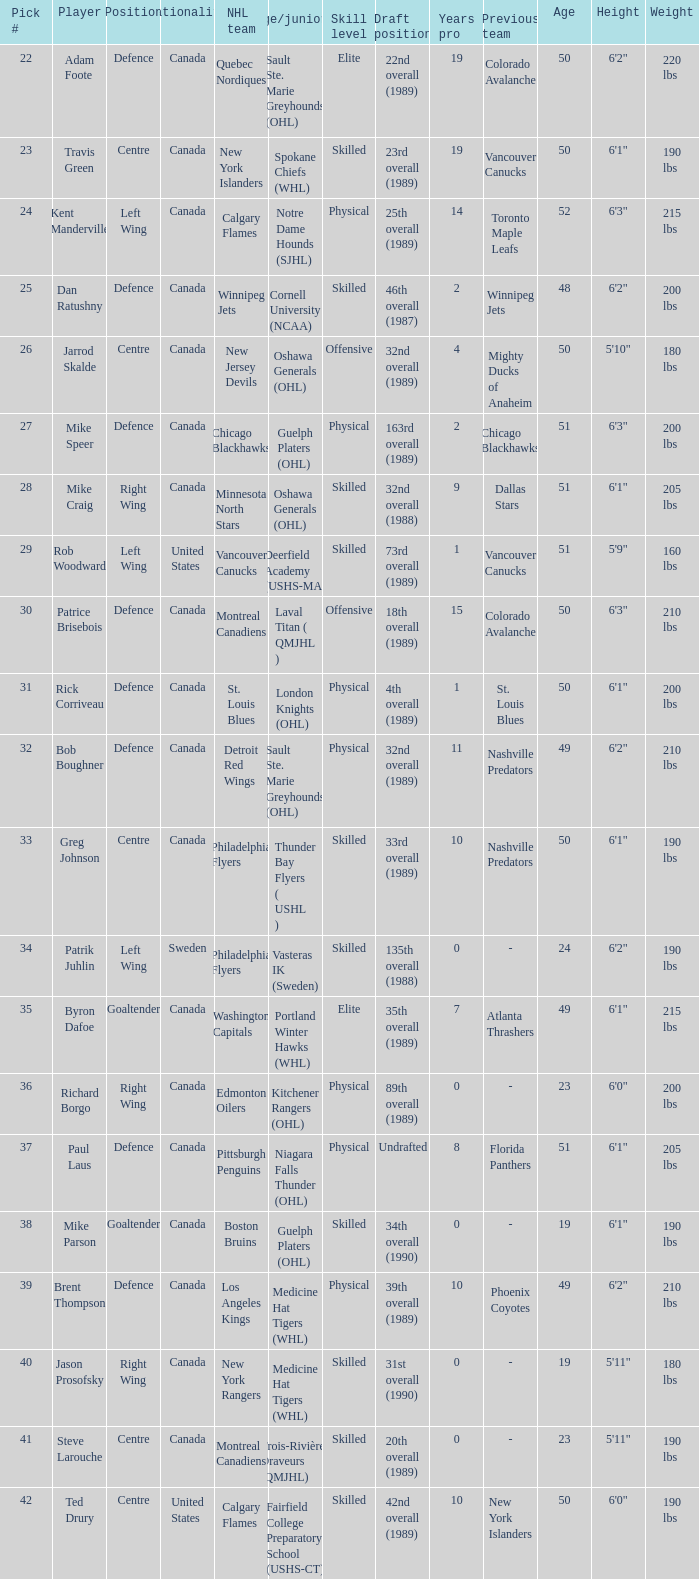What is the citizenship of the draft pick athlete who plays the center role and is joining the calgary flames? United States. 